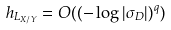Convert formula to latex. <formula><loc_0><loc_0><loc_500><loc_500>h _ { L _ { X / Y } } = O ( ( - \log | \sigma _ { D } | ) ^ { q } )</formula> 